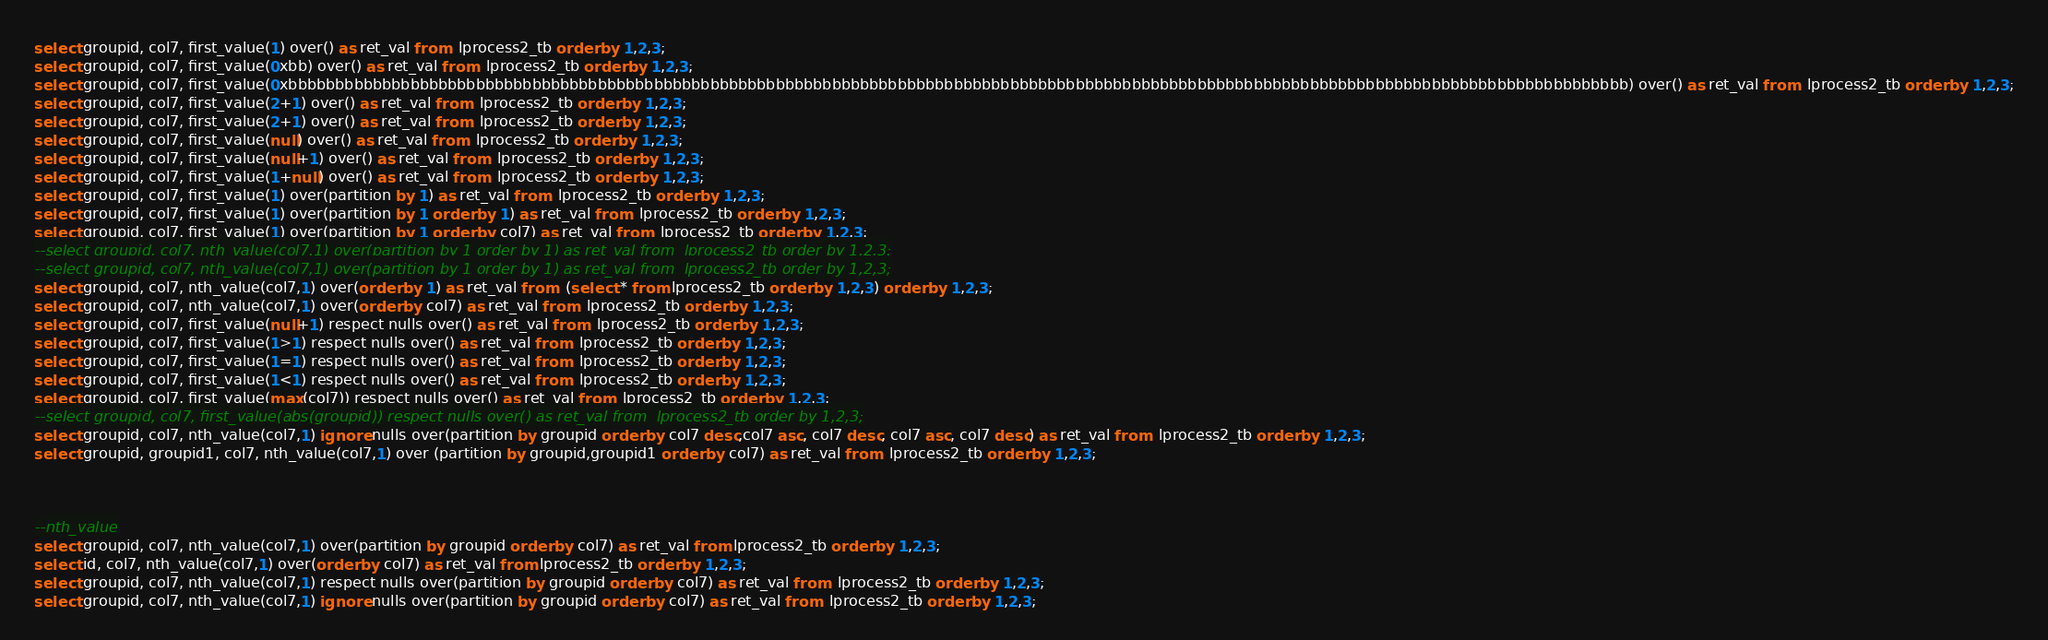<code> <loc_0><loc_0><loc_500><loc_500><_SQL_>select groupid, col7, first_value(1) over() as ret_val from  lprocess2_tb order by 1,2,3;
select groupid, col7, first_value(0xbb) over() as ret_val from  lprocess2_tb order by 1,2,3;
select groupid, col7, first_value(0xbbbbbbbbbbbbbbbbbbbbbbbbbbbbbbbbbbbbbbbbbbbbbbbbbbbbbbbbbbbbbbbbbbbbbbbbbbbbbbbbbbbbbbbbbbbbbbbbbbbbbbbbbbbbbbbbbbbbbbbbbbbbbbbbbbbbbbbbbbbbbbb) over() as ret_val from  lprocess2_tb order by 1,2,3;
select groupid, col7, first_value(2+1) over() as ret_val from  lprocess2_tb order by 1,2,3;
select groupid, col7, first_value(2+1) over() as ret_val from  lprocess2_tb order by 1,2,3;
select groupid, col7, first_value(null) over() as ret_val from  lprocess2_tb order by 1,2,3;
select groupid, col7, first_value(null+1) over() as ret_val from  lprocess2_tb order by 1,2,3;
select groupid, col7, first_value(1+null) over() as ret_val from  lprocess2_tb order by 1,2,3;
select groupid, col7, first_value(1) over(partition by 1) as ret_val from  lprocess2_tb order by 1,2,3;
select groupid, col7, first_value(1) over(partition by 1 order by 1) as ret_val from  lprocess2_tb order by 1,2,3;
select groupid, col7, first_value(1) over(partition by 1 order by col7) as ret_val from  lprocess2_tb order by 1,2,3;
--select groupid, col7, nth_value(col7,1) over(partition by 1 order by 1) as ret_val from  lprocess2_tb order by 1,2,3;
--select groupid, col7, nth_value(col7,1) over(partition by 1 order by 1) as ret_val from  lprocess2_tb order by 1,2,3;
select groupid, col7, nth_value(col7,1) over(order by 1) as ret_val from  (select * from lprocess2_tb order by 1,2,3) order by 1,2,3;
select groupid, col7, nth_value(col7,1) over(order by col7) as ret_val from  lprocess2_tb order by 1,2,3;
select groupid, col7, first_value(null+1) respect nulls over() as ret_val from  lprocess2_tb order by 1,2,3;
select groupid, col7, first_value(1>1) respect nulls over() as ret_val from  lprocess2_tb order by 1,2,3;
select groupid, col7, first_value(1=1) respect nulls over() as ret_val from  lprocess2_tb order by 1,2,3;
select groupid, col7, first_value(1<1) respect nulls over() as ret_val from  lprocess2_tb order by 1,2,3;
select groupid, col7, first_value(max(col7)) respect nulls over() as ret_val from  lprocess2_tb order by 1,2,3;
--select groupid, col7, first_value(abs(groupid)) respect nulls over() as ret_val from  lprocess2_tb order by 1,2,3;
select groupid, col7, nth_value(col7,1) ignore nulls over(partition by groupid order by col7 desc,col7 asc, col7 desc, col7 asc, col7 desc) as ret_val from  lprocess2_tb order by 1,2,3;
select groupid, groupid1, col7, nth_value(col7,1) over (partition by groupid,groupid1 order by col7) as ret_val from  lprocess2_tb order by 1,2,3;



--nth_value
select groupid, col7, nth_value(col7,1) over(partition by groupid order by col7) as ret_val from lprocess2_tb order by 1,2,3;
select id, col7, nth_value(col7,1) over(order by col7) as ret_val from lprocess2_tb order by 1,2,3;
select groupid, col7, nth_value(col7,1) respect nulls over(partition by groupid order by col7) as ret_val from  lprocess2_tb order by 1,2,3;
select groupid, col7, nth_value(col7,1) ignore nulls over(partition by groupid order by col7) as ret_val from  lprocess2_tb order by 1,2,3;</code> 